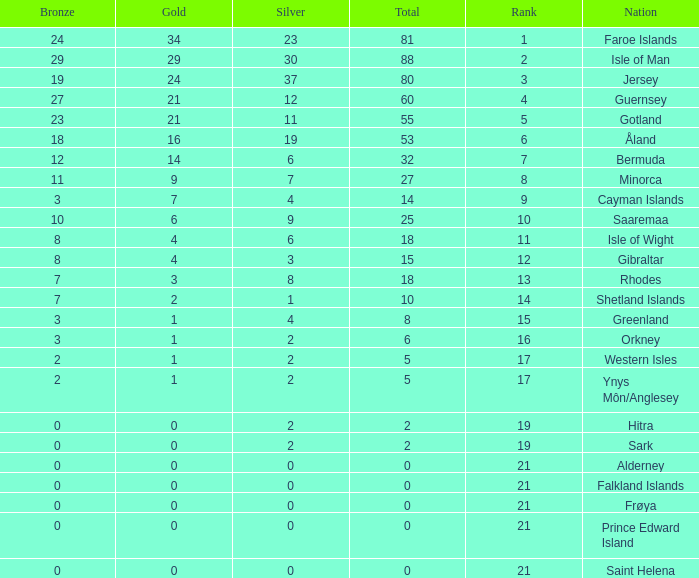How many Silver medals were won in total by all those with more than 3 bronze and exactly 16 gold? 19.0. 